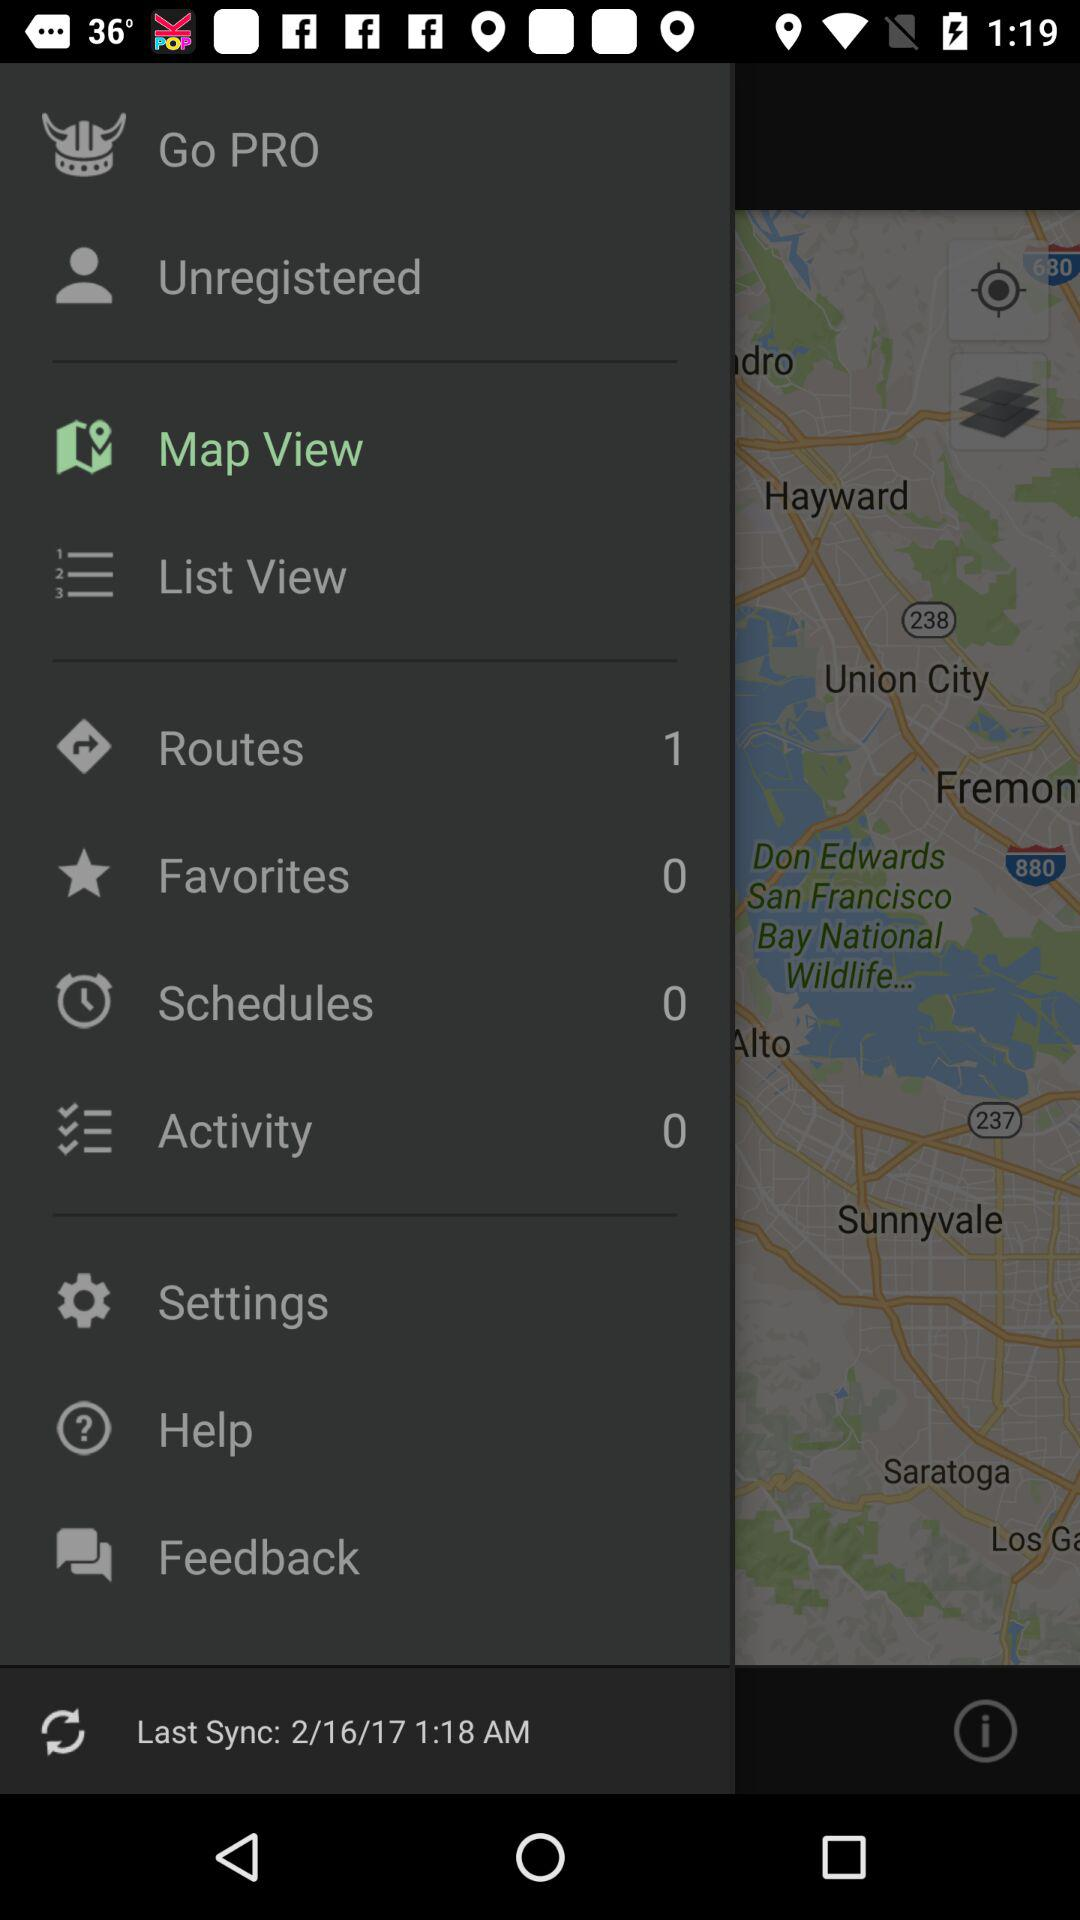How many notifications are there in "Settings"?
When the provided information is insufficient, respond with <no answer>. <no answer> 